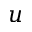<formula> <loc_0><loc_0><loc_500><loc_500>u</formula> 